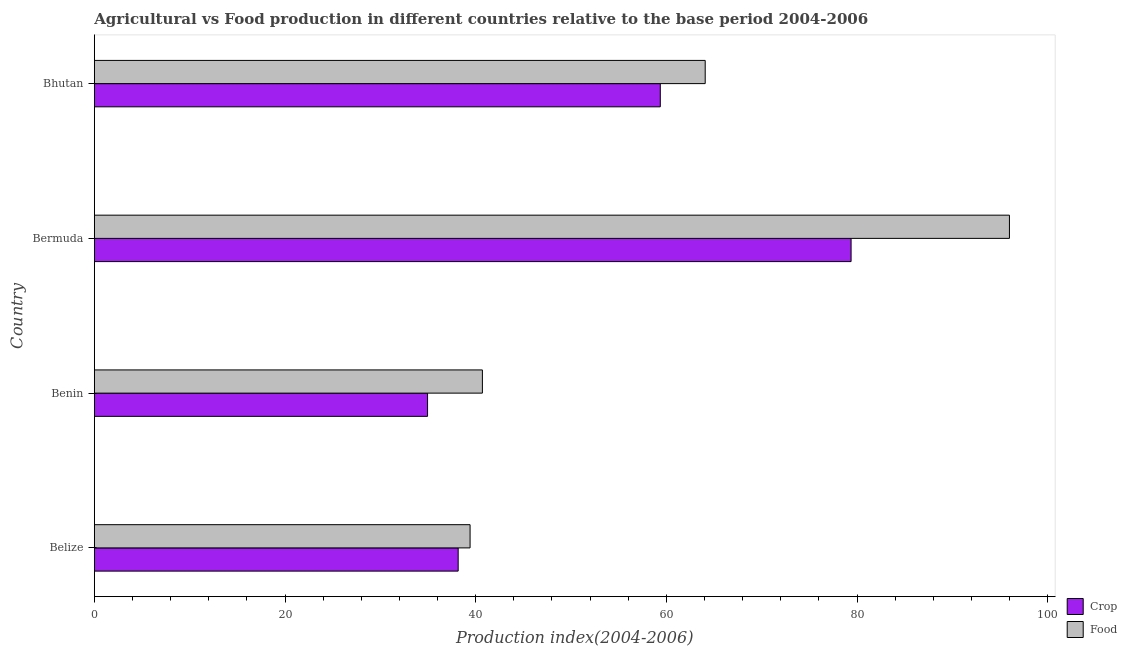How many groups of bars are there?
Provide a succinct answer. 4. Are the number of bars per tick equal to the number of legend labels?
Provide a short and direct response. Yes. Are the number of bars on each tick of the Y-axis equal?
Ensure brevity in your answer.  Yes. How many bars are there on the 1st tick from the top?
Your answer should be compact. 2. What is the label of the 1st group of bars from the top?
Your answer should be compact. Bhutan. In how many cases, is the number of bars for a given country not equal to the number of legend labels?
Your response must be concise. 0. What is the crop production index in Bhutan?
Give a very brief answer. 59.36. Across all countries, what is the maximum crop production index?
Provide a short and direct response. 79.37. Across all countries, what is the minimum crop production index?
Offer a terse response. 34.95. In which country was the food production index maximum?
Your answer should be compact. Bermuda. In which country was the crop production index minimum?
Your answer should be compact. Benin. What is the total food production index in the graph?
Ensure brevity in your answer.  240.16. What is the difference between the crop production index in Benin and that in Bhutan?
Your response must be concise. -24.41. What is the difference between the crop production index in Bermuda and the food production index in Belize?
Your answer should be very brief. 39.96. What is the average crop production index per country?
Keep it short and to the point. 52.96. In how many countries, is the crop production index greater than 52 ?
Your response must be concise. 2. What is the ratio of the food production index in Benin to that in Bhutan?
Your response must be concise. 0.64. What is the difference between the highest and the second highest crop production index?
Make the answer very short. 20.01. What is the difference between the highest and the lowest food production index?
Your response must be concise. 56.57. In how many countries, is the crop production index greater than the average crop production index taken over all countries?
Ensure brevity in your answer.  2. What does the 2nd bar from the top in Belize represents?
Your answer should be compact. Crop. What does the 1st bar from the bottom in Belize represents?
Ensure brevity in your answer.  Crop. Are all the bars in the graph horizontal?
Give a very brief answer. Yes. How many countries are there in the graph?
Your response must be concise. 4. What is the difference between two consecutive major ticks on the X-axis?
Make the answer very short. 20. Does the graph contain any zero values?
Your answer should be compact. No. What is the title of the graph?
Your answer should be very brief. Agricultural vs Food production in different countries relative to the base period 2004-2006. Does "Fixed telephone" appear as one of the legend labels in the graph?
Make the answer very short. No. What is the label or title of the X-axis?
Your answer should be very brief. Production index(2004-2006). What is the label or title of the Y-axis?
Your answer should be very brief. Country. What is the Production index(2004-2006) in Crop in Belize?
Your answer should be very brief. 38.16. What is the Production index(2004-2006) in Food in Belize?
Your answer should be very brief. 39.41. What is the Production index(2004-2006) of Crop in Benin?
Provide a succinct answer. 34.95. What is the Production index(2004-2006) of Food in Benin?
Make the answer very short. 40.7. What is the Production index(2004-2006) in Crop in Bermuda?
Provide a succinct answer. 79.37. What is the Production index(2004-2006) of Food in Bermuda?
Provide a succinct answer. 95.98. What is the Production index(2004-2006) of Crop in Bhutan?
Keep it short and to the point. 59.36. What is the Production index(2004-2006) in Food in Bhutan?
Provide a short and direct response. 64.07. Across all countries, what is the maximum Production index(2004-2006) in Crop?
Ensure brevity in your answer.  79.37. Across all countries, what is the maximum Production index(2004-2006) in Food?
Your response must be concise. 95.98. Across all countries, what is the minimum Production index(2004-2006) in Crop?
Keep it short and to the point. 34.95. Across all countries, what is the minimum Production index(2004-2006) of Food?
Your answer should be very brief. 39.41. What is the total Production index(2004-2006) of Crop in the graph?
Provide a succinct answer. 211.84. What is the total Production index(2004-2006) of Food in the graph?
Make the answer very short. 240.16. What is the difference between the Production index(2004-2006) in Crop in Belize and that in Benin?
Provide a succinct answer. 3.21. What is the difference between the Production index(2004-2006) of Food in Belize and that in Benin?
Your response must be concise. -1.29. What is the difference between the Production index(2004-2006) in Crop in Belize and that in Bermuda?
Keep it short and to the point. -41.21. What is the difference between the Production index(2004-2006) in Food in Belize and that in Bermuda?
Keep it short and to the point. -56.57. What is the difference between the Production index(2004-2006) in Crop in Belize and that in Bhutan?
Ensure brevity in your answer.  -21.2. What is the difference between the Production index(2004-2006) in Food in Belize and that in Bhutan?
Provide a short and direct response. -24.66. What is the difference between the Production index(2004-2006) in Crop in Benin and that in Bermuda?
Your answer should be very brief. -44.42. What is the difference between the Production index(2004-2006) of Food in Benin and that in Bermuda?
Offer a very short reply. -55.28. What is the difference between the Production index(2004-2006) of Crop in Benin and that in Bhutan?
Provide a short and direct response. -24.41. What is the difference between the Production index(2004-2006) of Food in Benin and that in Bhutan?
Ensure brevity in your answer.  -23.37. What is the difference between the Production index(2004-2006) of Crop in Bermuda and that in Bhutan?
Provide a succinct answer. 20.01. What is the difference between the Production index(2004-2006) of Food in Bermuda and that in Bhutan?
Your answer should be very brief. 31.91. What is the difference between the Production index(2004-2006) in Crop in Belize and the Production index(2004-2006) in Food in Benin?
Provide a succinct answer. -2.54. What is the difference between the Production index(2004-2006) in Crop in Belize and the Production index(2004-2006) in Food in Bermuda?
Offer a terse response. -57.82. What is the difference between the Production index(2004-2006) in Crop in Belize and the Production index(2004-2006) in Food in Bhutan?
Make the answer very short. -25.91. What is the difference between the Production index(2004-2006) in Crop in Benin and the Production index(2004-2006) in Food in Bermuda?
Ensure brevity in your answer.  -61.03. What is the difference between the Production index(2004-2006) of Crop in Benin and the Production index(2004-2006) of Food in Bhutan?
Provide a succinct answer. -29.12. What is the average Production index(2004-2006) in Crop per country?
Your answer should be compact. 52.96. What is the average Production index(2004-2006) in Food per country?
Give a very brief answer. 60.04. What is the difference between the Production index(2004-2006) of Crop and Production index(2004-2006) of Food in Belize?
Keep it short and to the point. -1.25. What is the difference between the Production index(2004-2006) of Crop and Production index(2004-2006) of Food in Benin?
Provide a short and direct response. -5.75. What is the difference between the Production index(2004-2006) of Crop and Production index(2004-2006) of Food in Bermuda?
Make the answer very short. -16.61. What is the difference between the Production index(2004-2006) of Crop and Production index(2004-2006) of Food in Bhutan?
Offer a very short reply. -4.71. What is the ratio of the Production index(2004-2006) of Crop in Belize to that in Benin?
Keep it short and to the point. 1.09. What is the ratio of the Production index(2004-2006) in Food in Belize to that in Benin?
Your response must be concise. 0.97. What is the ratio of the Production index(2004-2006) in Crop in Belize to that in Bermuda?
Ensure brevity in your answer.  0.48. What is the ratio of the Production index(2004-2006) in Food in Belize to that in Bermuda?
Make the answer very short. 0.41. What is the ratio of the Production index(2004-2006) of Crop in Belize to that in Bhutan?
Your answer should be compact. 0.64. What is the ratio of the Production index(2004-2006) of Food in Belize to that in Bhutan?
Give a very brief answer. 0.62. What is the ratio of the Production index(2004-2006) in Crop in Benin to that in Bermuda?
Ensure brevity in your answer.  0.44. What is the ratio of the Production index(2004-2006) of Food in Benin to that in Bermuda?
Provide a short and direct response. 0.42. What is the ratio of the Production index(2004-2006) of Crop in Benin to that in Bhutan?
Ensure brevity in your answer.  0.59. What is the ratio of the Production index(2004-2006) in Food in Benin to that in Bhutan?
Provide a succinct answer. 0.64. What is the ratio of the Production index(2004-2006) of Crop in Bermuda to that in Bhutan?
Keep it short and to the point. 1.34. What is the ratio of the Production index(2004-2006) of Food in Bermuda to that in Bhutan?
Give a very brief answer. 1.5. What is the difference between the highest and the second highest Production index(2004-2006) in Crop?
Offer a very short reply. 20.01. What is the difference between the highest and the second highest Production index(2004-2006) of Food?
Your answer should be very brief. 31.91. What is the difference between the highest and the lowest Production index(2004-2006) of Crop?
Your answer should be compact. 44.42. What is the difference between the highest and the lowest Production index(2004-2006) in Food?
Offer a very short reply. 56.57. 